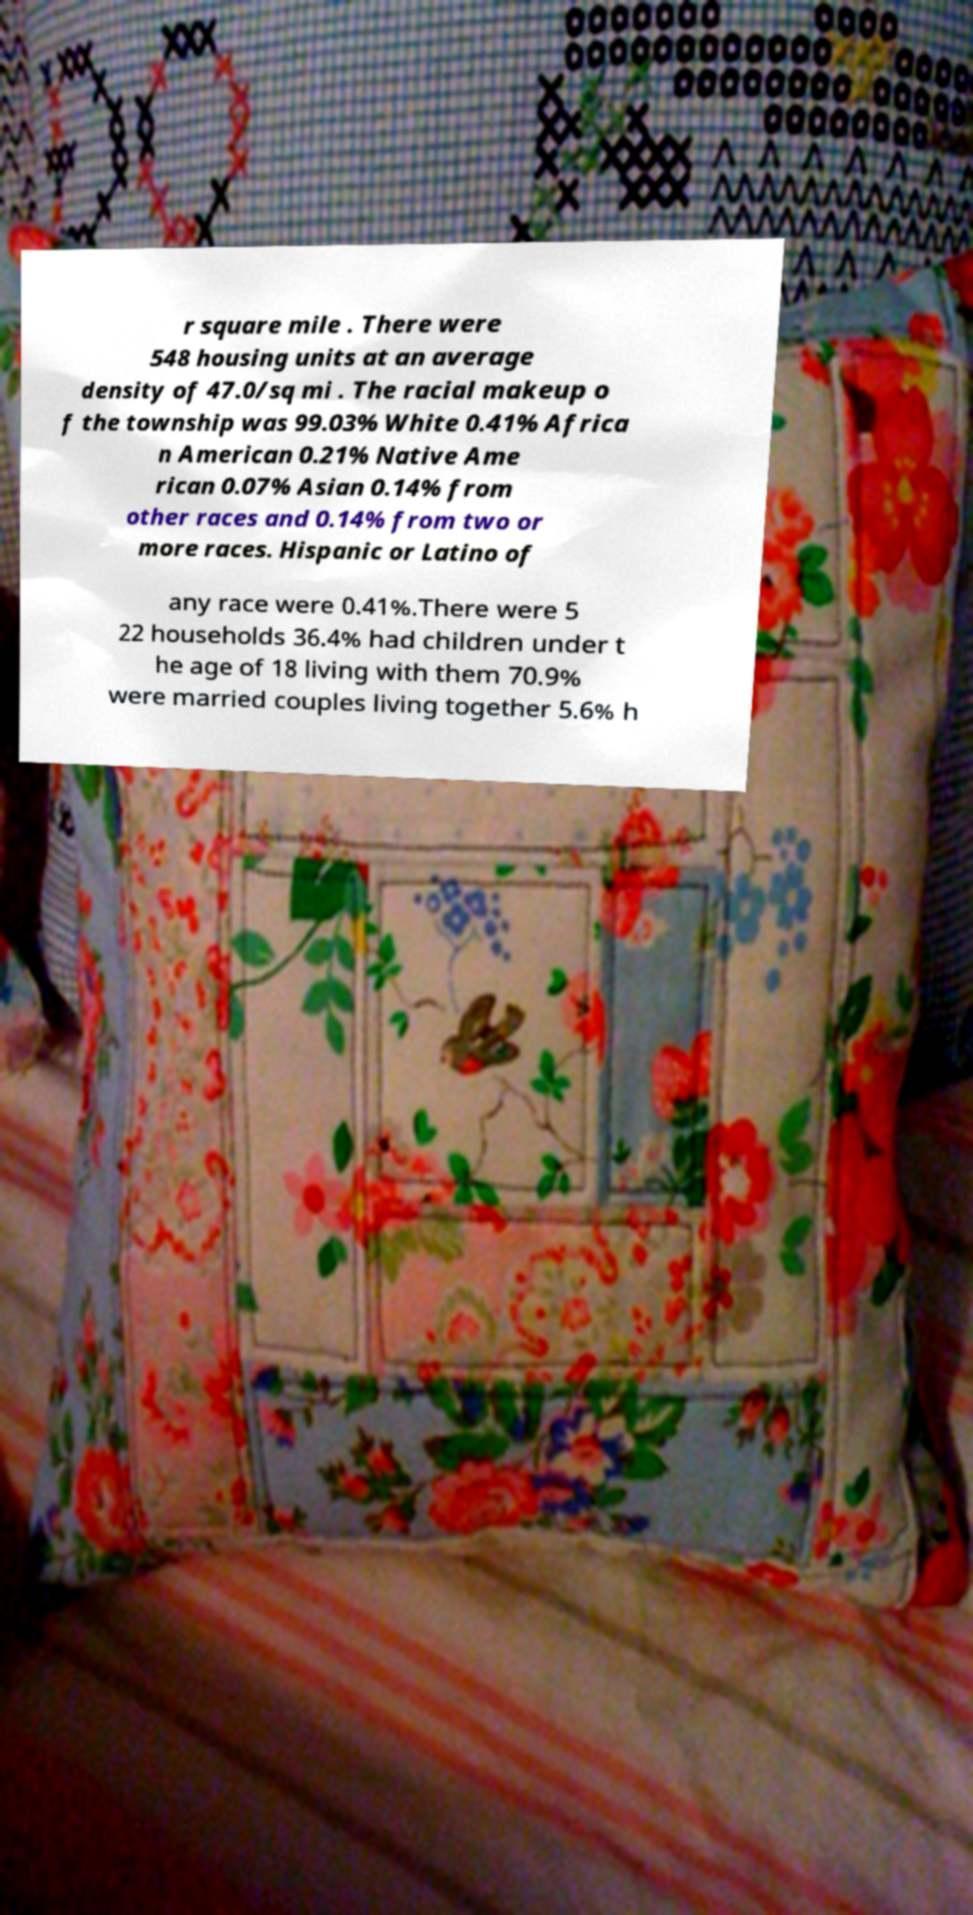For documentation purposes, I need the text within this image transcribed. Could you provide that? r square mile . There were 548 housing units at an average density of 47.0/sq mi . The racial makeup o f the township was 99.03% White 0.41% Africa n American 0.21% Native Ame rican 0.07% Asian 0.14% from other races and 0.14% from two or more races. Hispanic or Latino of any race were 0.41%.There were 5 22 households 36.4% had children under t he age of 18 living with them 70.9% were married couples living together 5.6% h 